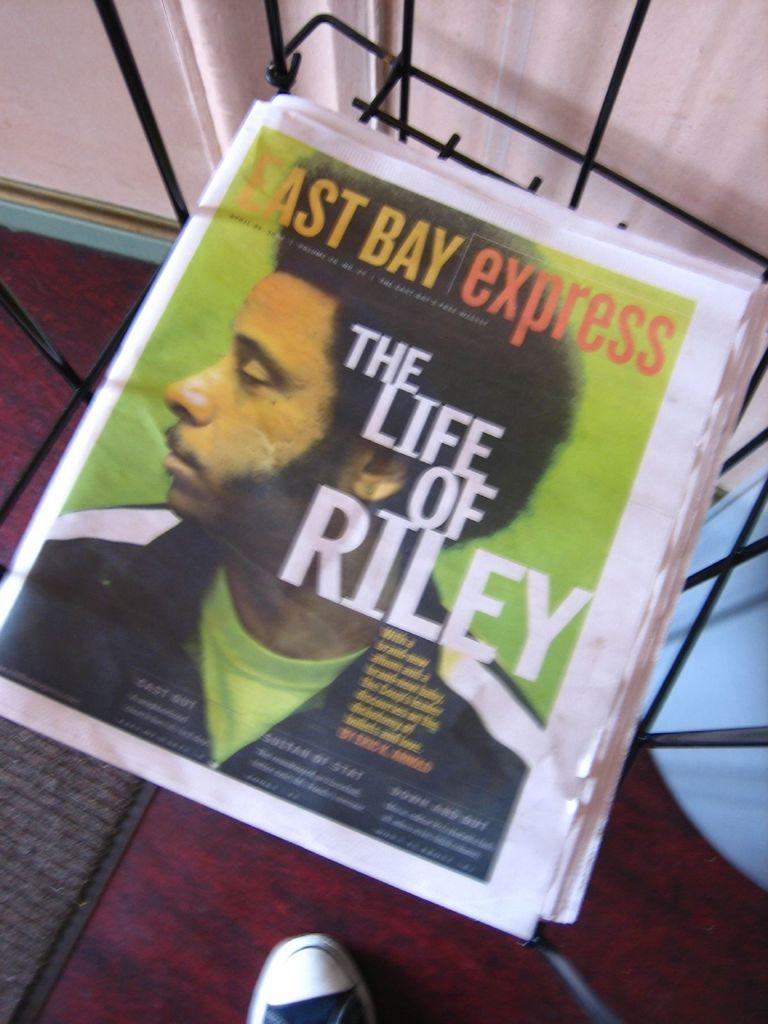What is placed on the stand in the image? There are papers on a stand in the image. What might the papers be used for? The papers on the stand might be used for displaying information or for reading. Can you describe the stand in the image? The stand is likely a flat surface with a vertical support, designed to hold the papers in place. What type of door can be seen in the image? There is no door present in the image; it only features papers on a stand. 